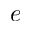<formula> <loc_0><loc_0><loc_500><loc_500>e</formula> 